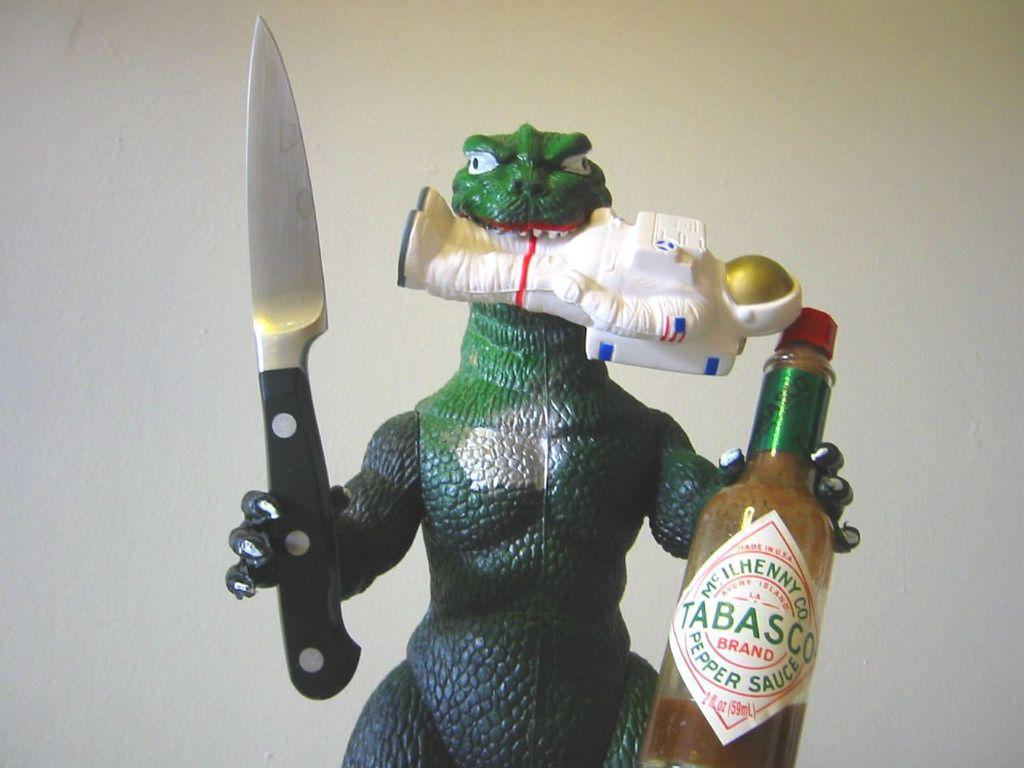What type of toy is present in the image? There is a dragon toy in the image. What is the dragon toy holding in its right hand? The dragon toy is holding a knife in its right hand. What is the dragon toy holding in its left hand? The dragon toy is holding a bottle in its left hand. What type of coil is present in the image? There is no coil present in the image. 